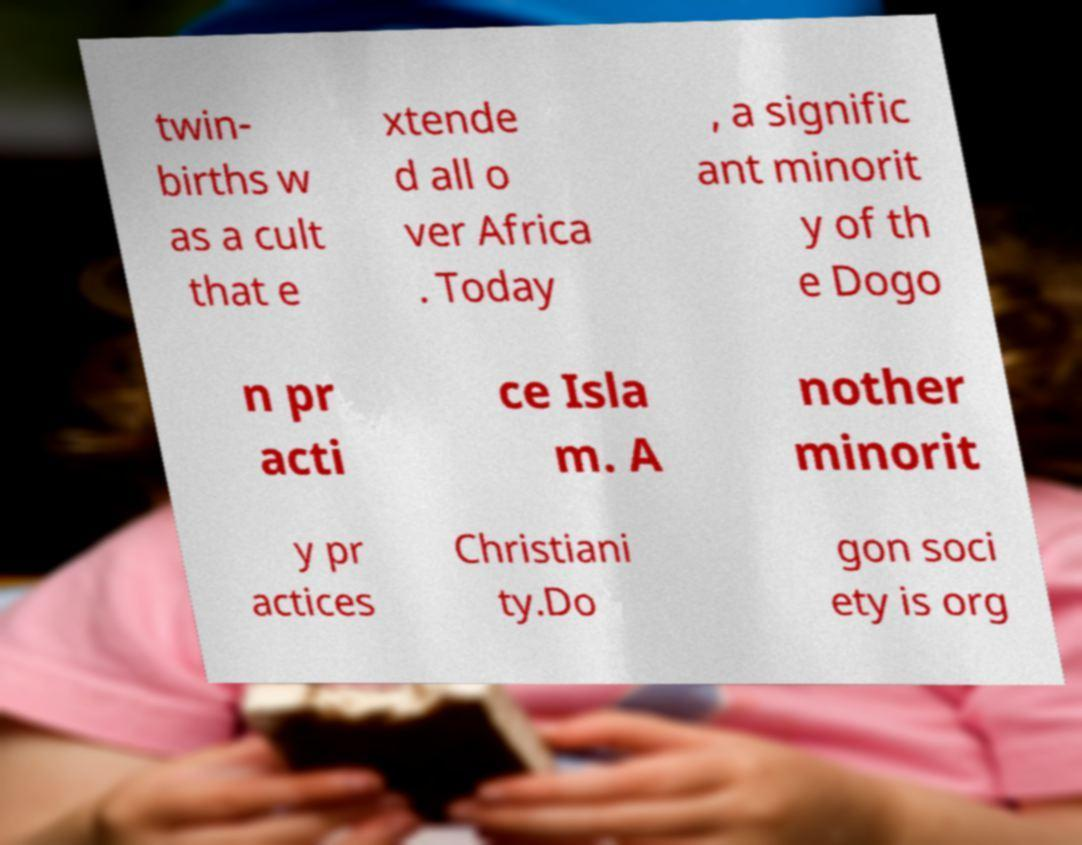Could you assist in decoding the text presented in this image and type it out clearly? twin- births w as a cult that e xtende d all o ver Africa . Today , a signific ant minorit y of th e Dogo n pr acti ce Isla m. A nother minorit y pr actices Christiani ty.Do gon soci ety is org 